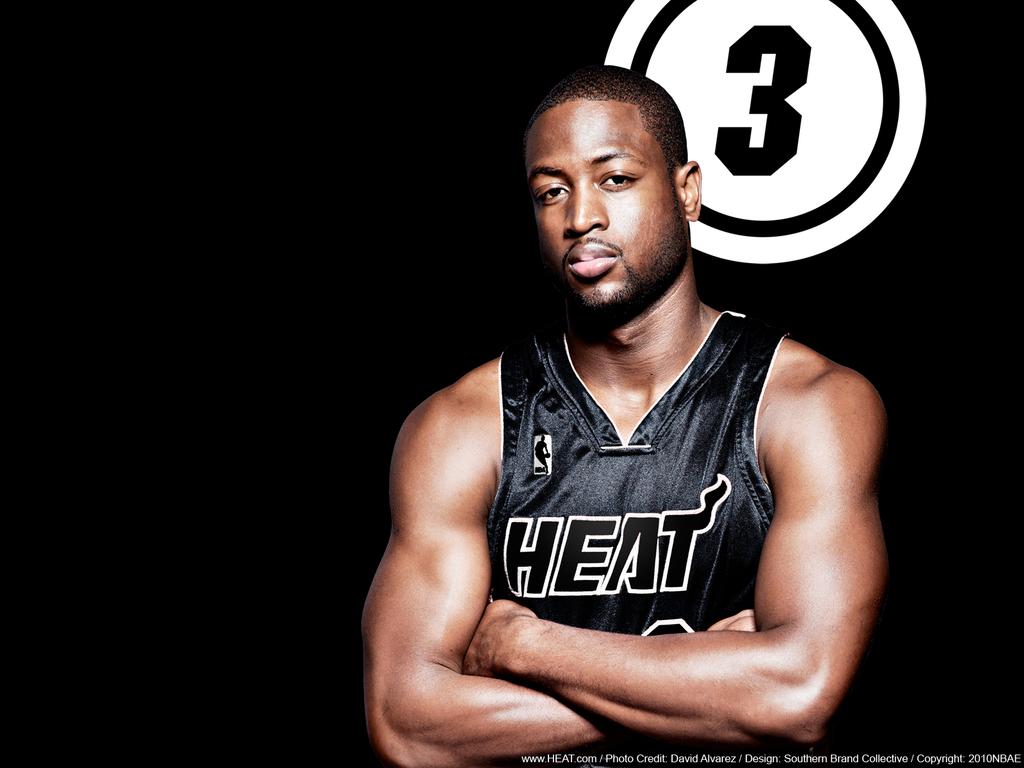What team does he play for?
Your answer should be compact. Heat. What is the number displayed behind the player?
Offer a very short reply. 3. 